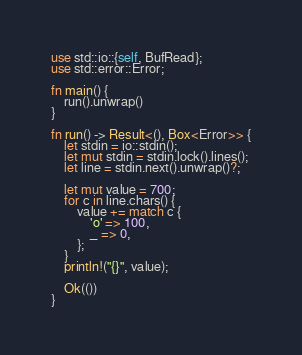<code> <loc_0><loc_0><loc_500><loc_500><_Rust_>use std::io::{self, BufRead};
use std::error::Error;

fn main() {
    run().unwrap()
}

fn run() -> Result<(), Box<Error>> {
    let stdin = io::stdin();
    let mut stdin = stdin.lock().lines();
    let line = stdin.next().unwrap()?;
    
    let mut value = 700;
    for c in line.chars() {
        value += match c {
            'o' => 100,
            _ => 0,
        };
    }
    println!("{}", value);

    Ok(())
}
</code> 